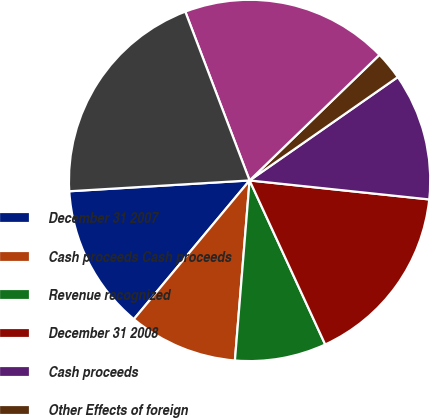Convert chart. <chart><loc_0><loc_0><loc_500><loc_500><pie_chart><fcel>December 31 2007<fcel>Cash proceeds Cash proceeds<fcel>Revenue recognized<fcel>December 31 2008<fcel>Cash proceeds<fcel>Other Effects of foreign<fcel>December 31 2009<fcel>Current liabilities<nl><fcel>12.98%<fcel>9.77%<fcel>8.17%<fcel>16.45%<fcel>11.37%<fcel>2.54%<fcel>18.56%<fcel>20.16%<nl></chart> 